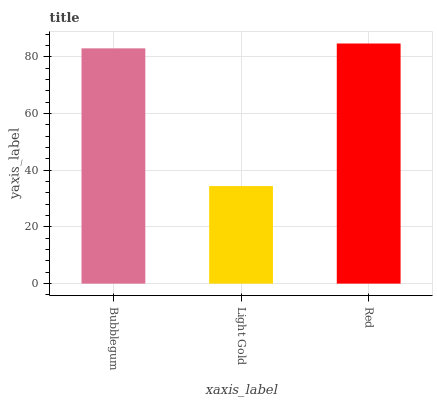Is Light Gold the minimum?
Answer yes or no. Yes. Is Red the maximum?
Answer yes or no. Yes. Is Red the minimum?
Answer yes or no. No. Is Light Gold the maximum?
Answer yes or no. No. Is Red greater than Light Gold?
Answer yes or no. Yes. Is Light Gold less than Red?
Answer yes or no. Yes. Is Light Gold greater than Red?
Answer yes or no. No. Is Red less than Light Gold?
Answer yes or no. No. Is Bubblegum the high median?
Answer yes or no. Yes. Is Bubblegum the low median?
Answer yes or no. Yes. Is Light Gold the high median?
Answer yes or no. No. Is Light Gold the low median?
Answer yes or no. No. 